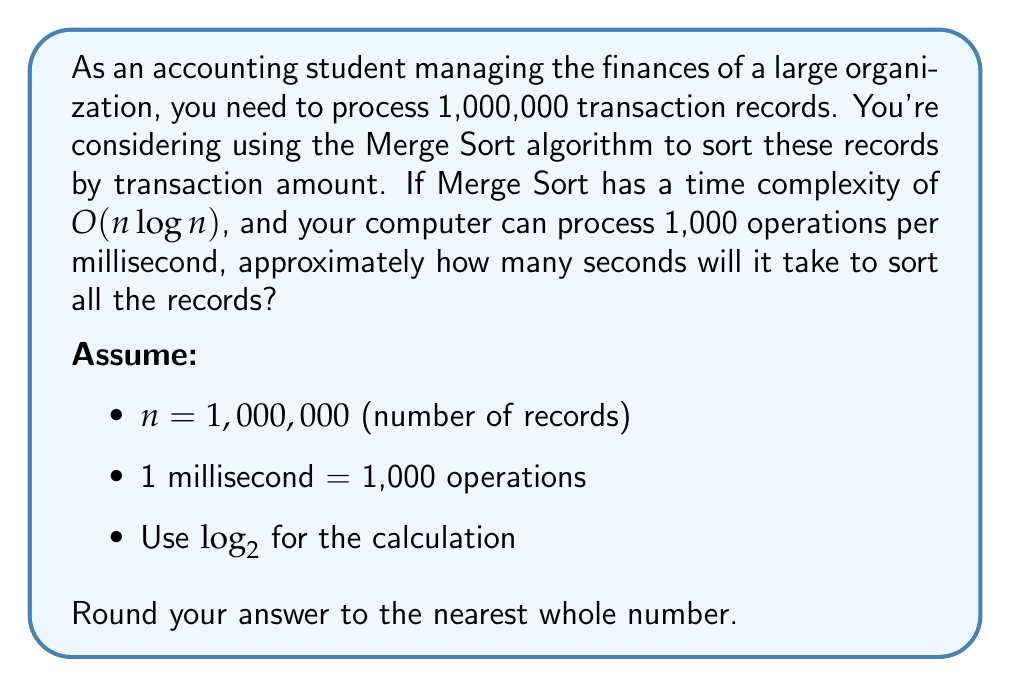Could you help me with this problem? Let's approach this step-by-step:

1) The time complexity of Merge Sort is $O(n \log n)$. This means the number of operations is approximately $n \log n$.

2) In this case, $n = 1,000,000$, so we need to calculate:

   $$1,000,000 \times \log_2(1,000,000)$$

3) First, let's calculate $\log_2(1,000,000)$:
   
   $$\log_2(1,000,000) \approx 19.93$$

4) Now, multiply this by 1,000,000:

   $$1,000,000 \times 19.93 \approx 19,930,000$$

5) This is the approximate number of operations needed.

6) We're told that the computer can process 1,000 operations per millisecond. To find the number of milliseconds, we divide by 1,000:

   $$\frac{19,930,000}{1,000} = 19,930$$ milliseconds

7) To convert milliseconds to seconds, we divide by 1,000 again:

   $$\frac{19,930}{1,000} = 19.93$$ seconds

8) Rounding to the nearest whole number:

   $$19.93 \approx 20$$ seconds
Answer: 20 seconds 